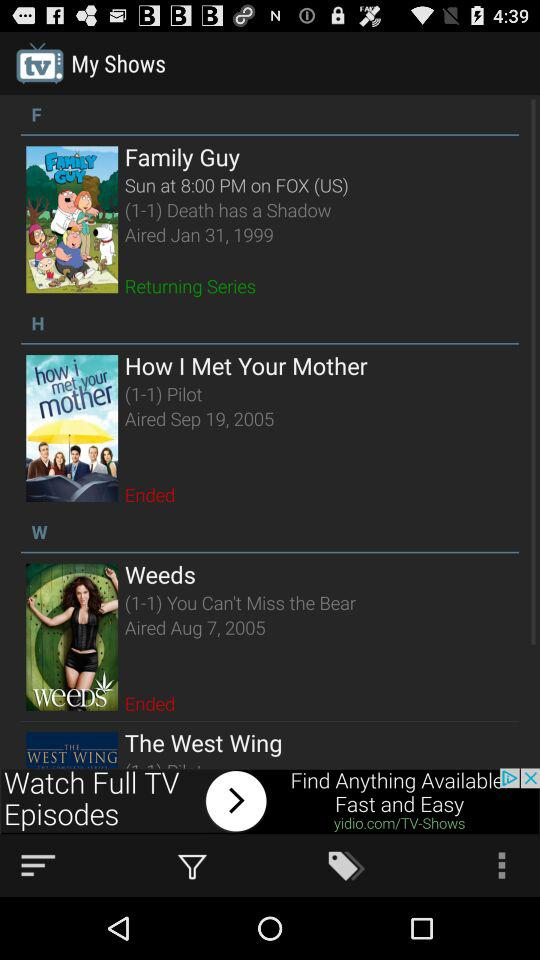What is the time of the Family Guy series? The time is 8:00 PM. 